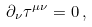Convert formula to latex. <formula><loc_0><loc_0><loc_500><loc_500>\partial _ { \nu } \tau ^ { \mu \nu } = 0 \, ,</formula> 